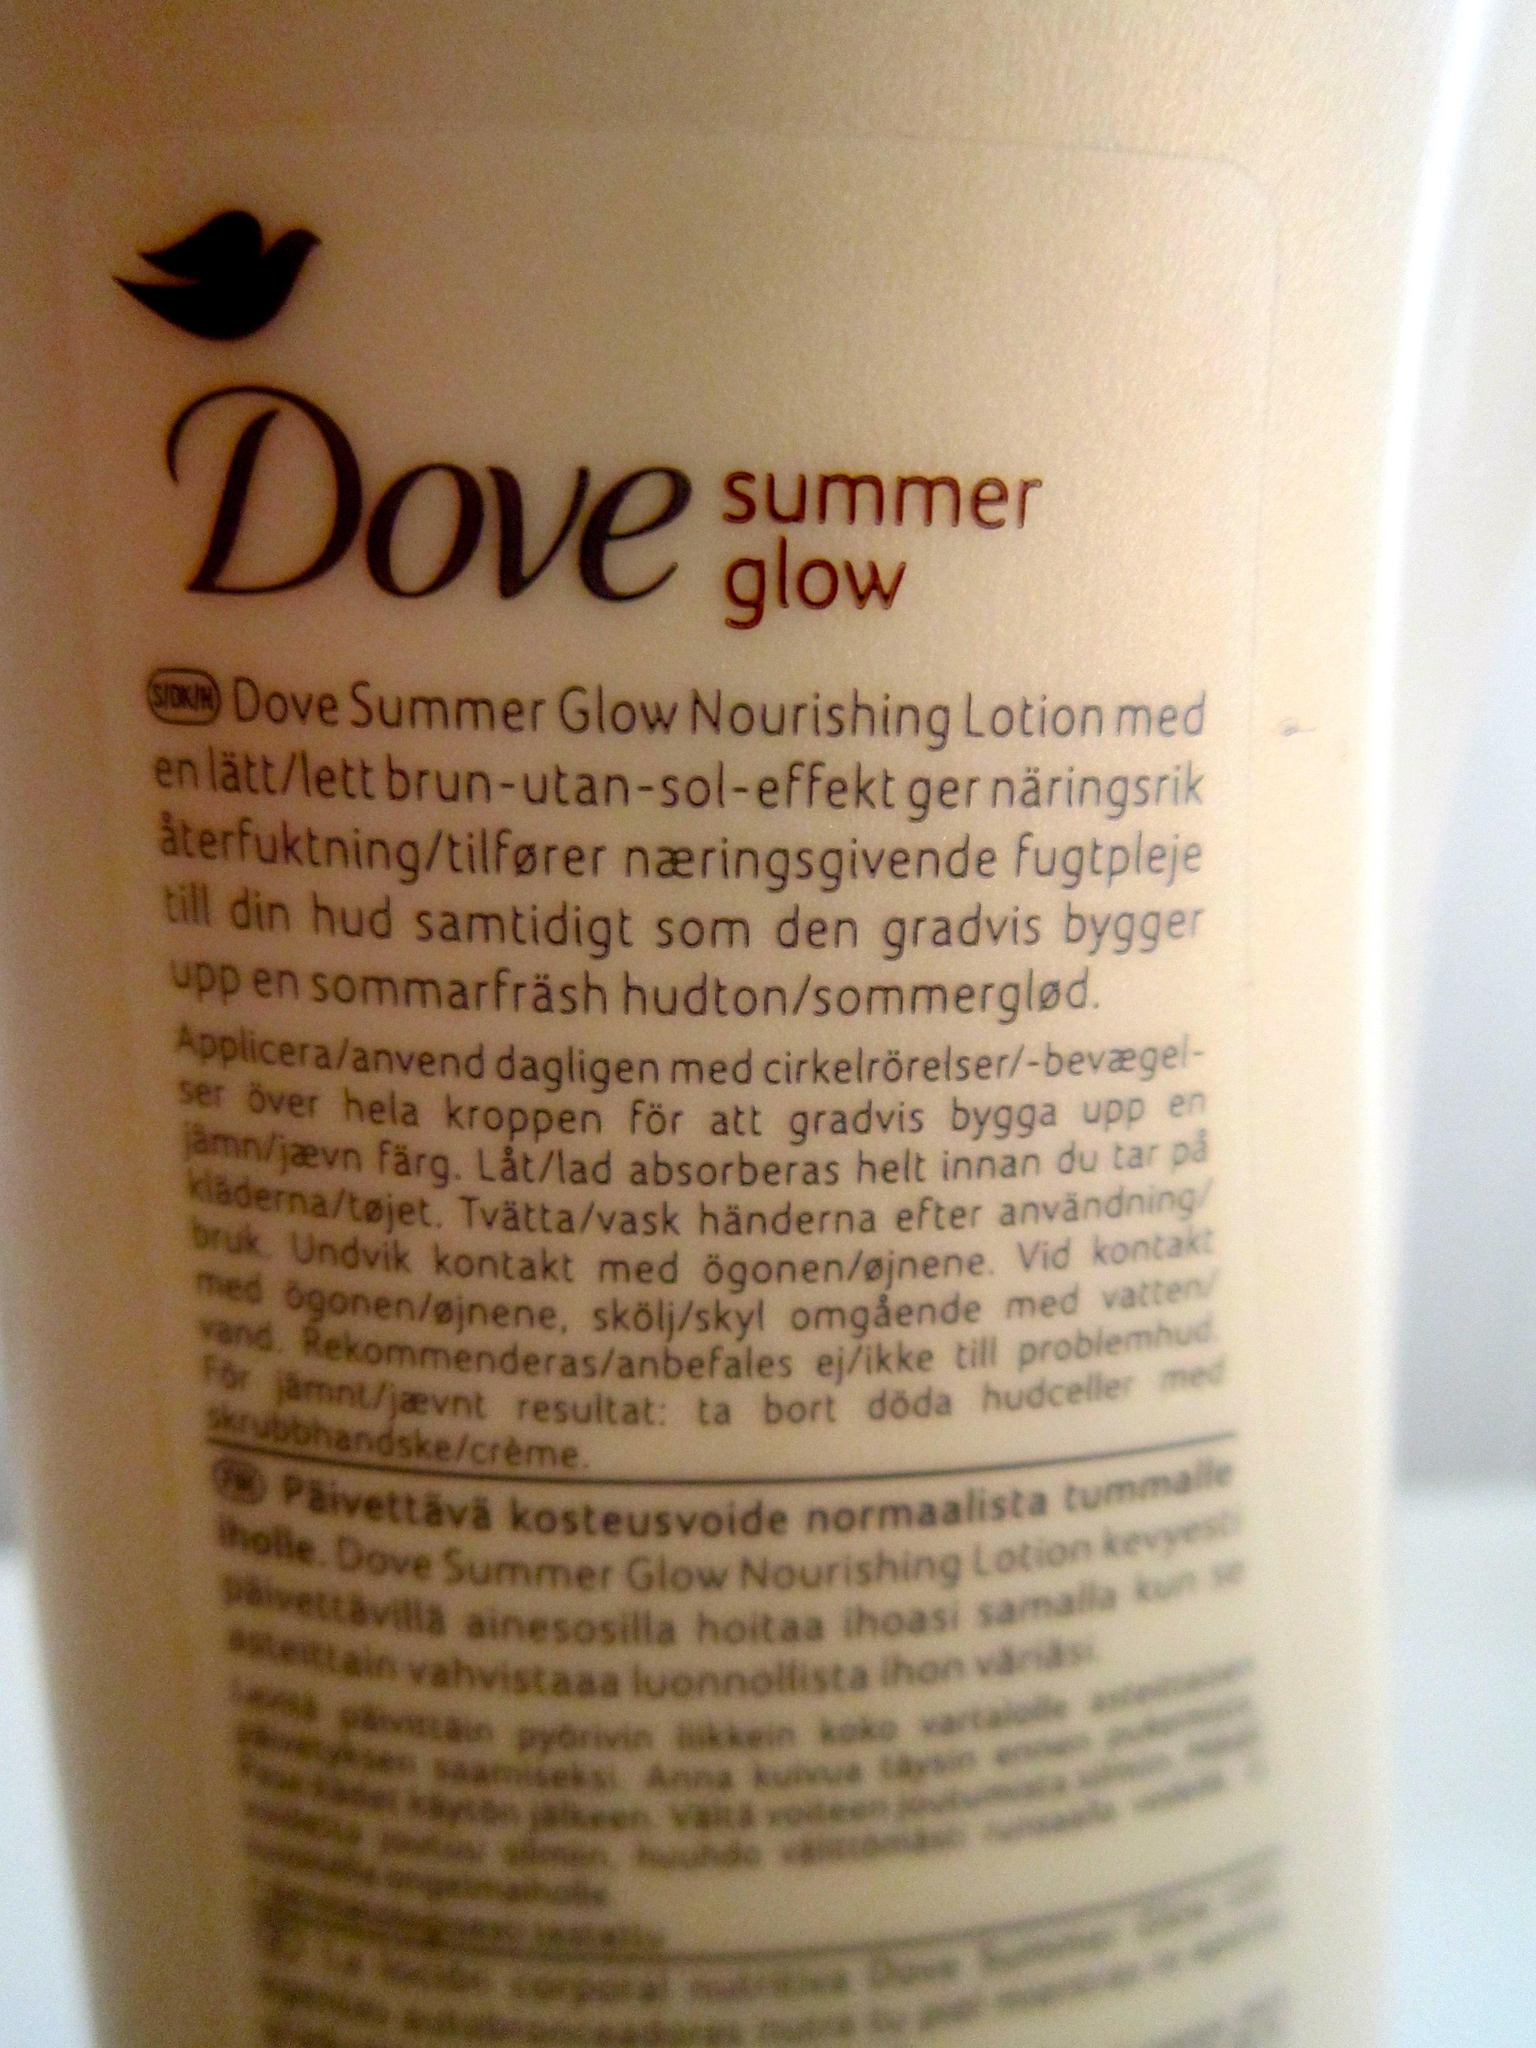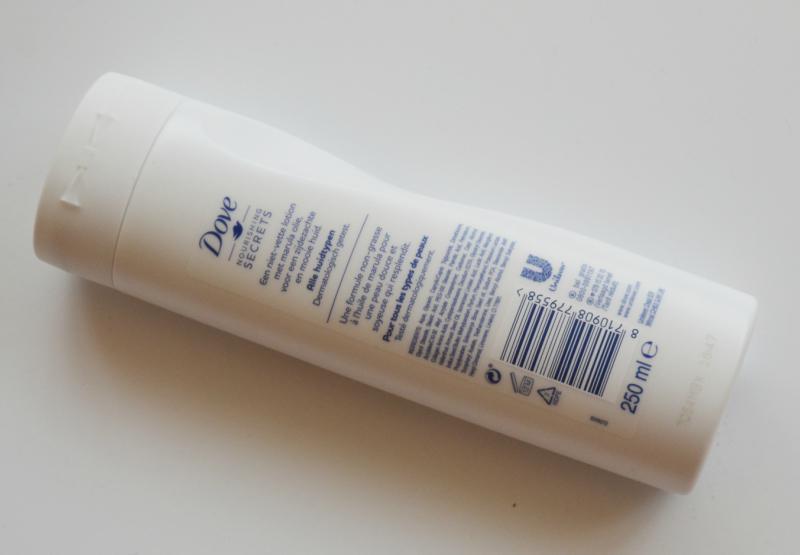The first image is the image on the left, the second image is the image on the right. Examine the images to the left and right. Is the description "In the image on the right, the bottle of soap has a top pump dispenser." accurate? Answer yes or no. No. The first image is the image on the left, the second image is the image on the right. Examine the images to the left and right. Is the description "The right image contains one pump-top product with its nozzle facing left, and the left image contains a product without a pump top." accurate? Answer yes or no. No. 